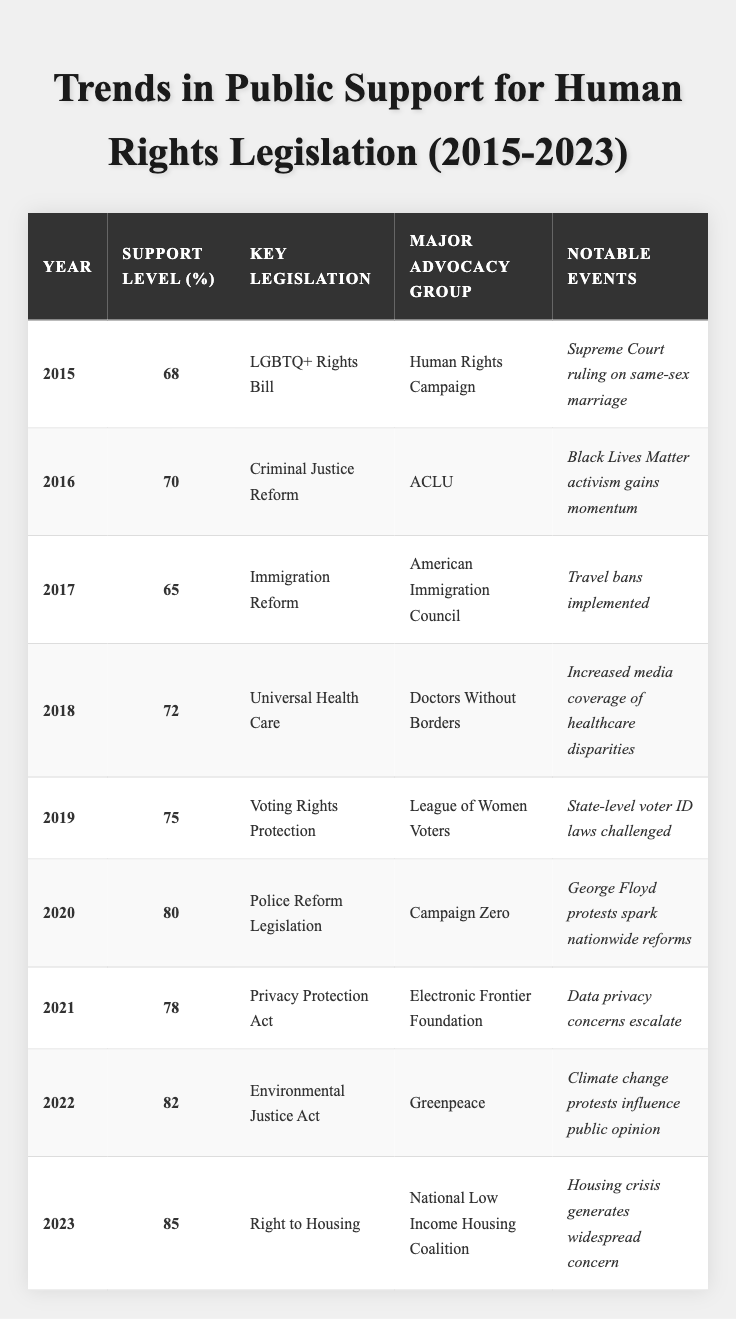What was the support level for human rights legislation in 2015? The table shows the value for the year 2015 listed under 'Support Level (%)', which is 68%.
Answer: 68% Which year saw the highest support level for human rights legislation? The table can be scanned to find that the highest support level, 85%, is recorded in 2023.
Answer: 2023 What key legislation was associated with the support level of 80%? By checking the table for the year with a 80% support level, which is 2020, the corresponding key legislation is identified as "Police Reform Legislation."
Answer: Police Reform Legislation How much did support for human rights legislation increase from 2015 to 2023? The support level in 2015 was 68%, and in 2023 it is 85%. Subtracting these gives a difference of 85 - 68 = 17%.
Answer: 17% Was the support for criminal justice reform higher than for immigration reform? The support level for criminal justice reform in 2016 is 70%, while for immigration reform in 2017, it is 65%. Since 70% is greater than 65%, the answer is yes.
Answer: Yes What notable event in 2020 influenced the public support for human rights legislation? According to the table, the notable event in 2020 is stated as "George Floyd protests spark nationwide reforms," which likely contributed to the increase in support that year.
Answer: George Floyd protests What was the average support level for human rights legislation from 2015 to 2023? The support levels from 2015 to 2023 are: 68%, 70%, 65%, 72%, 75%, 80%, 78%, 82%, and 85%. Summing these values gives 68 + 70 + 65 + 72 + 75 + 80 + 78 + 82 + 85 =  685. There are 9 data points, so the average is 685 / 9 ≈ 76.1%.
Answer: 76.1% In which year did support decline compared to the previous year? The only year where support decreased compared to the preceding year is 2017, where support fell from 70% in 2016 to 65%.
Answer: 2017 What advocacy group was associated with the highest support level noted in the table? The highest support level of 85% in 2023 corresponds to the "National Low Income Housing Coalition" as the major advocacy group.
Answer: National Low Income Housing Coalition What trend can be observed in public support levels from 2015 to 2023? By examining the values in the table, the support levels show a general upward trend from 68% in 2015 to 85% in 2023, indicating increasing public support for human rights legislation over the years.
Answer: Increasing trend 